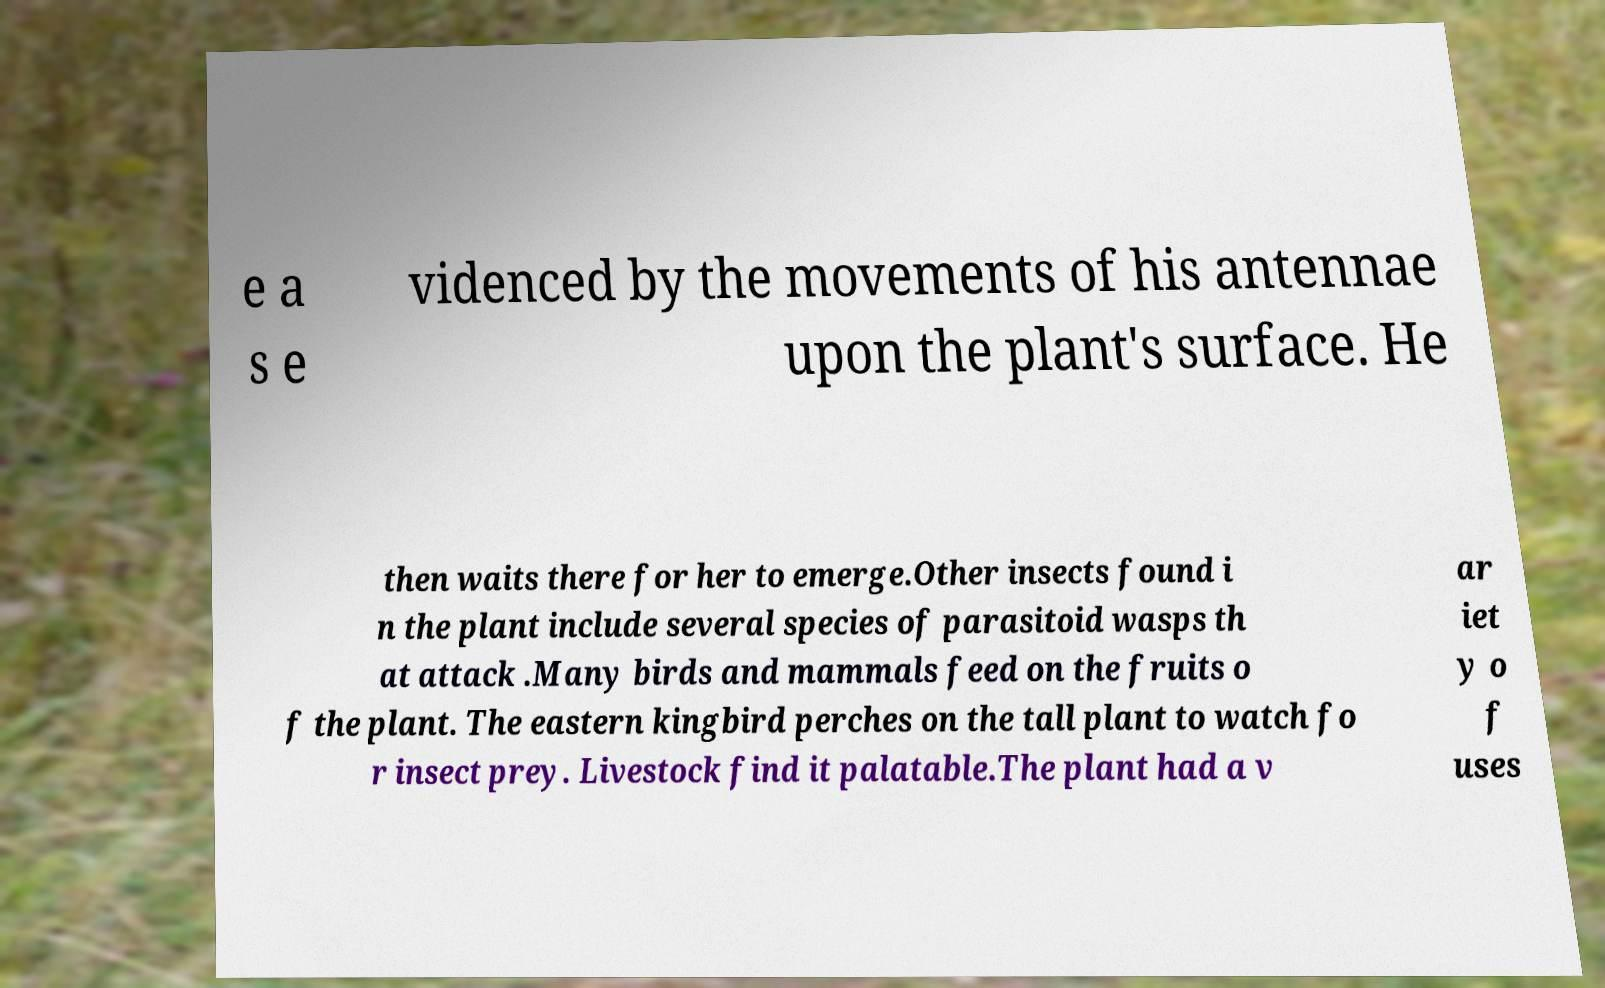Can you read and provide the text displayed in the image?This photo seems to have some interesting text. Can you extract and type it out for me? e a s e videnced by the movements of his antennae upon the plant's surface. He then waits there for her to emerge.Other insects found i n the plant include several species of parasitoid wasps th at attack .Many birds and mammals feed on the fruits o f the plant. The eastern kingbird perches on the tall plant to watch fo r insect prey. Livestock find it palatable.The plant had a v ar iet y o f uses 